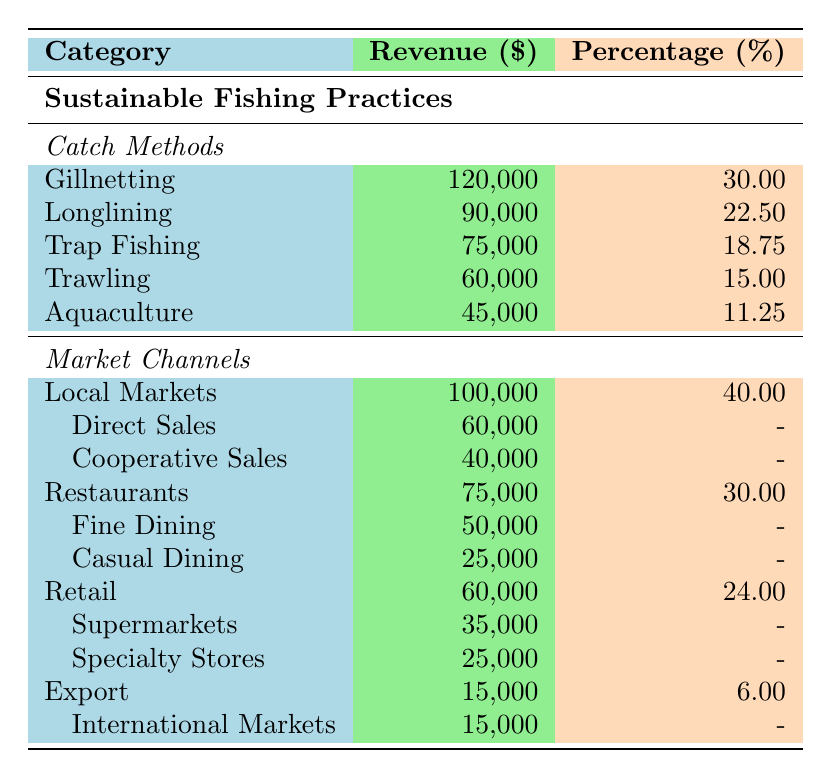What is the total revenue generated from Gillnetting? The revenue for Gillnetting is listed in the table as 120,000. Therefore, the total revenue generated from Gillnetting is directly read from the table.
Answer: 120,000 Which catch method contributes the least to revenue? Looking at the revenue listed for all catch methods, Aquaculture has the lowest revenue at 45,000. Therefore, Aquaculture is the catch method that contributes the least.
Answer: Aquaculture What percentage of total revenue comes from Local Markets? The table indicates that Local Markets generate a revenue of 100,000 and contribute 40% to the total revenue. This percentage is read directly from the table.
Answer: 40 What is the combined revenue of Trap Fishing and Trawling? The revenue for Trap Fishing is 75,000 and for Trawling is 60,000. Adding these together: 75,000 + 60,000 = 135,000 gives the combined revenue of both catch methods.
Answer: 135,000 Are Restaurants generating more revenue than Retail? The revenue for Restaurants is 75,000, and for Retail, it's 60,000. Since 75,000 is greater than 60,000, it is true that Restaurants are generating more revenue than Retail.
Answer: Yes What is the percentage contribution of Aquaculture compared to the total revenue from all catch methods? Aquaculture has a revenue of 45,000, and the total revenue from all catch methods is 120,000 + 90,000 + 75,000 + 60,000 + 45,000 = 390,000. The percentage contribution is calculated as (45,000 / 390,000) * 100, which equals 11.54%. This value confirms the percentage contribution from the table.
Answer: 11.54 How much revenue is generated from Fine Dining compared to Casual Dining? Revenue from Fine Dining is 50,000 and from Casual Dining is 25,000. The difference is calculated as 50,000 - 25,000 = 25,000, indicating Fine Dining generates 25,000 more than Casual Dining.
Answer: 25,000 What is the total percentage contributed by all Market Channels? To find the total percentage, we add the percentages of Local Markets (40%), Restaurants (30%), Retail (24%), and Export (6%) together: 40 + 30 + 24 + 6 = 100%. This shows that all market channels sum up to a total of 100%.
Answer: 100% What revenue comes from Direct Sales and Cooperative Sales combined? The revenue from Direct Sales is 60,000 and from Cooperative Sales is 40,000. Adding these together: 60,000 + 40,000 = 100,000 gives us the total revenue from both types of sales.
Answer: 100,000 